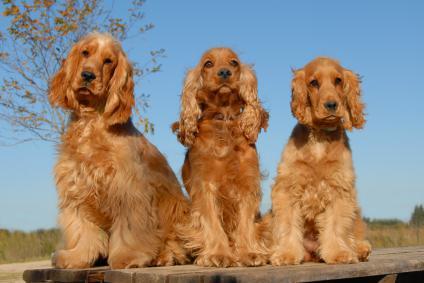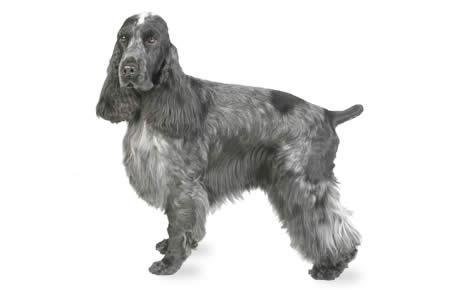The first image is the image on the left, the second image is the image on the right. For the images shown, is this caption "There are three dogs in one of the images." true? Answer yes or no. Yes. 